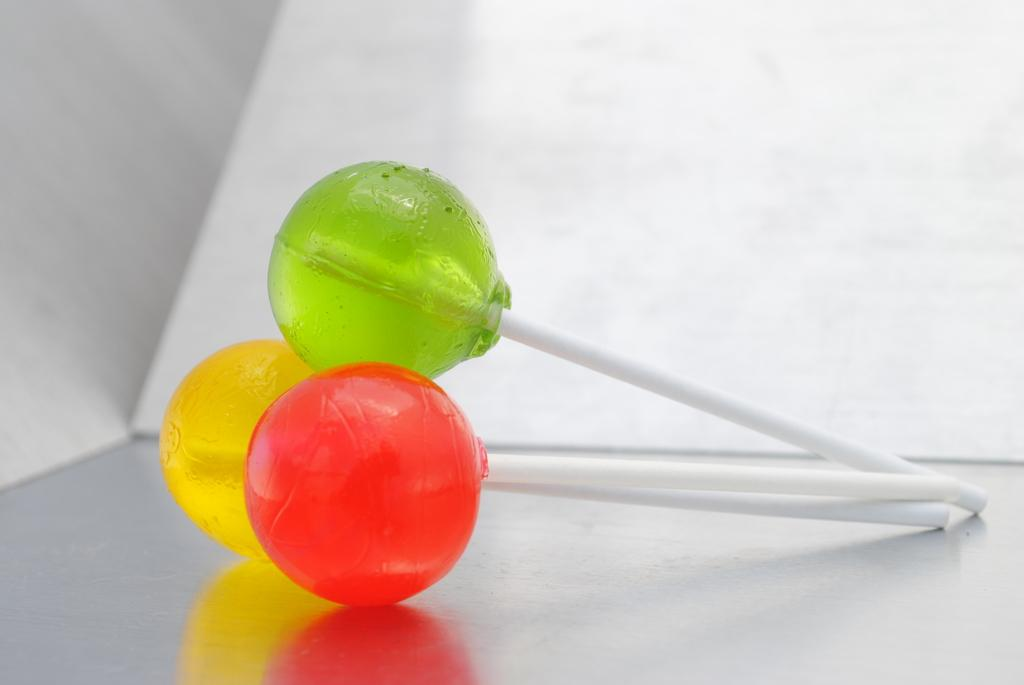How many lollipops are visible in the image? There are three lollipops in the image. What distinguishes the lollipops from one another? The lollipops are of different flavors. Where are the lollipops placed in the image? The lollipops are placed on a platform. Can you see a deer standing on the platform with the lollipops in the image? No, there is no deer present in the image. 